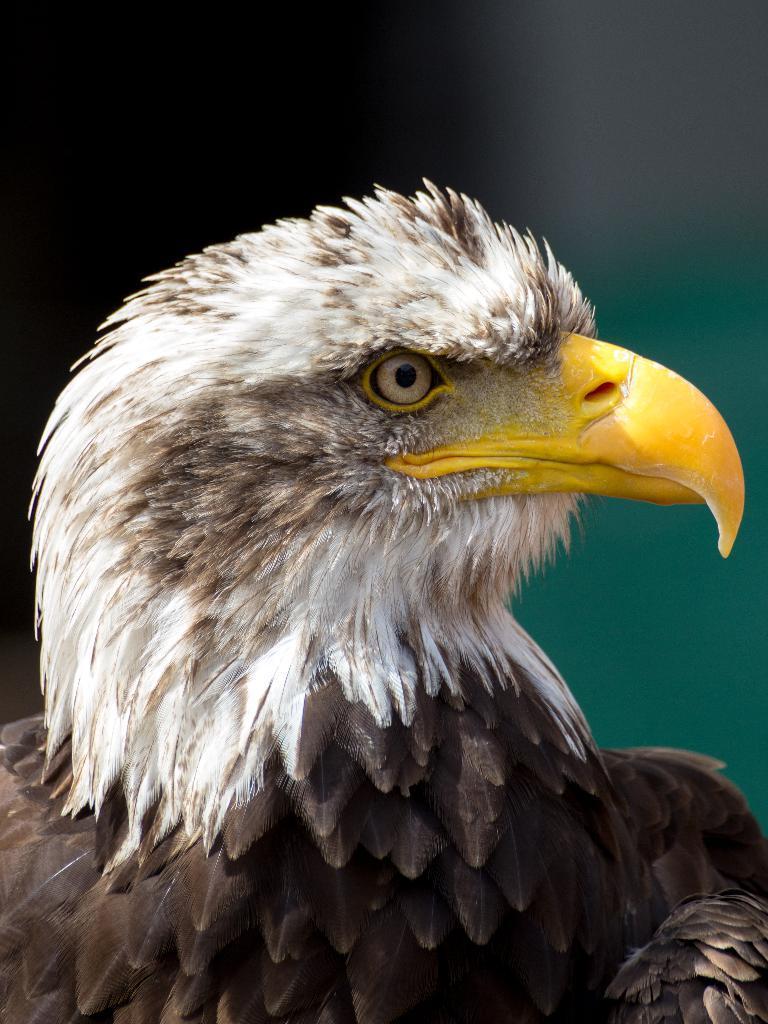Can you describe this image briefly? In this image there is a bird. 